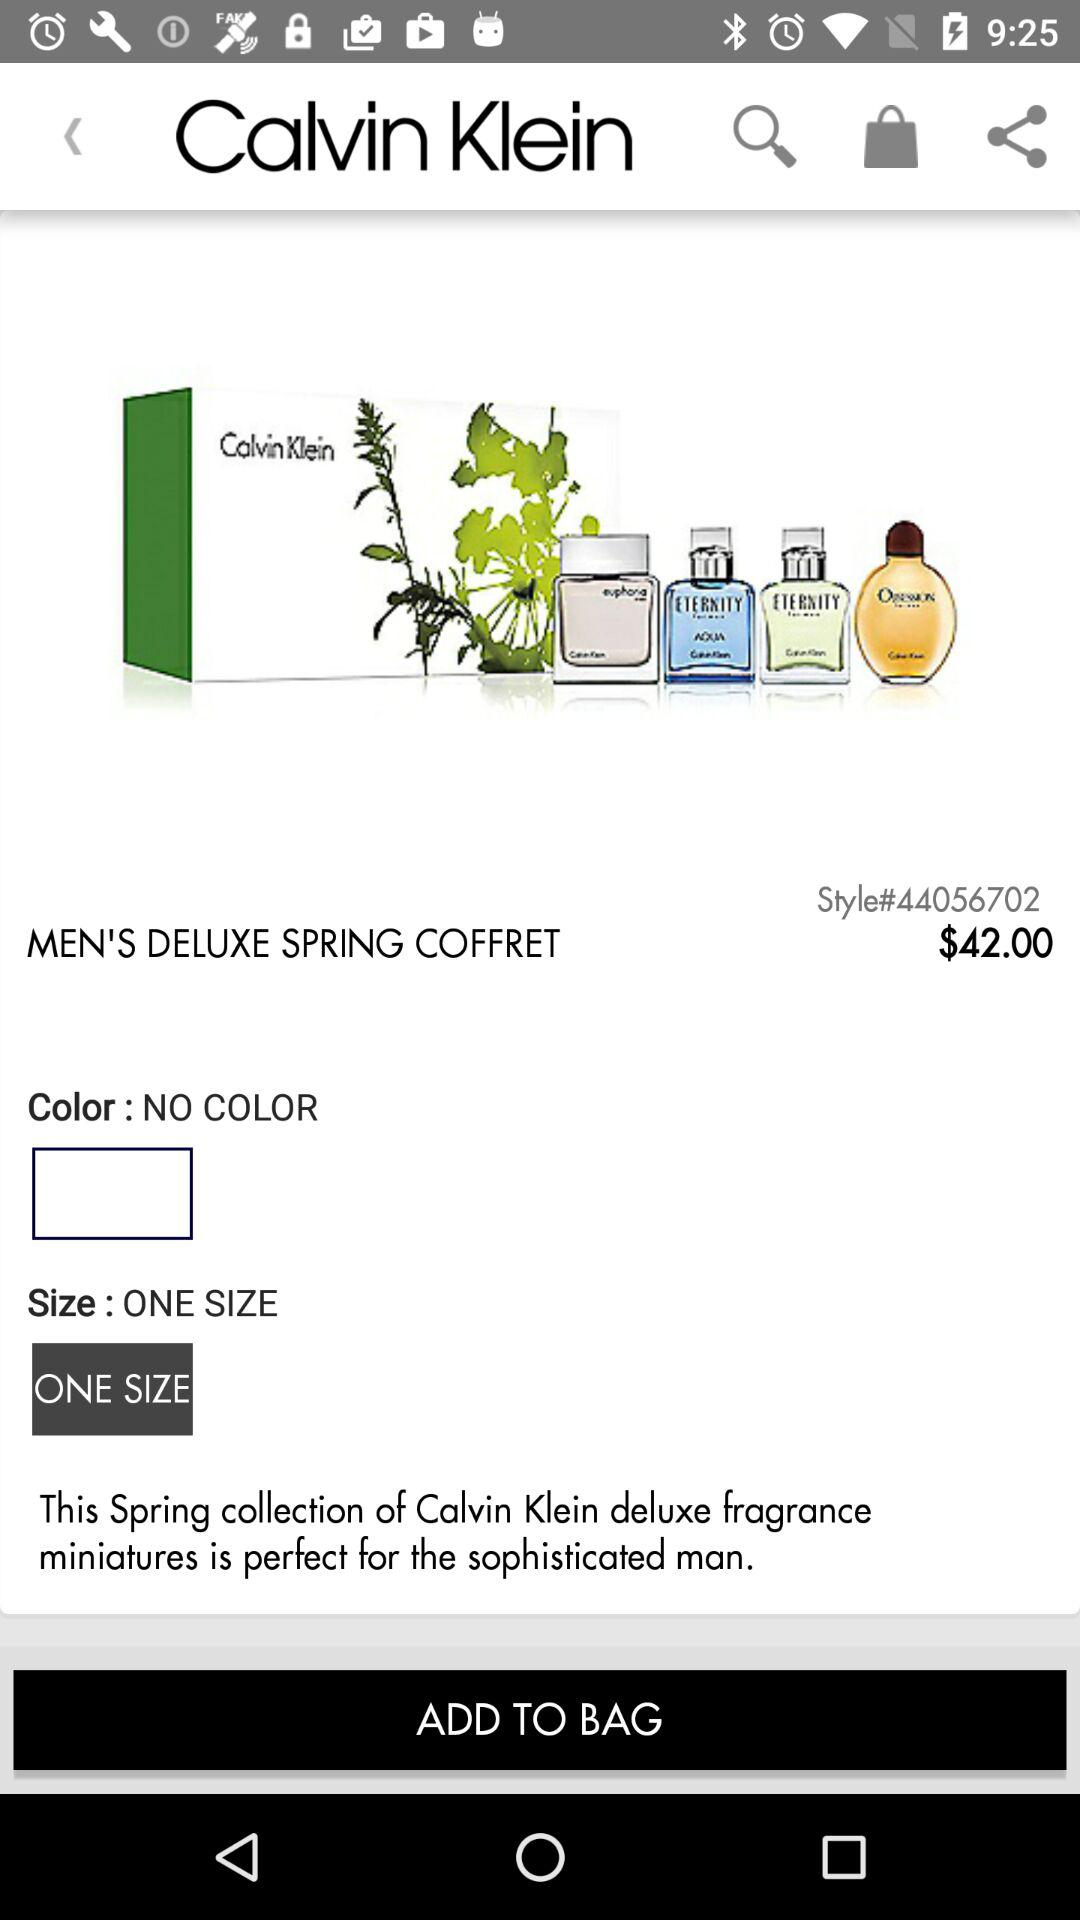What is the style code of "MEN'S DELUXE SPRING COFFRET" product? The style code of the product "MEN'S DELUXE SPRING COFFRET" is 44056702. 